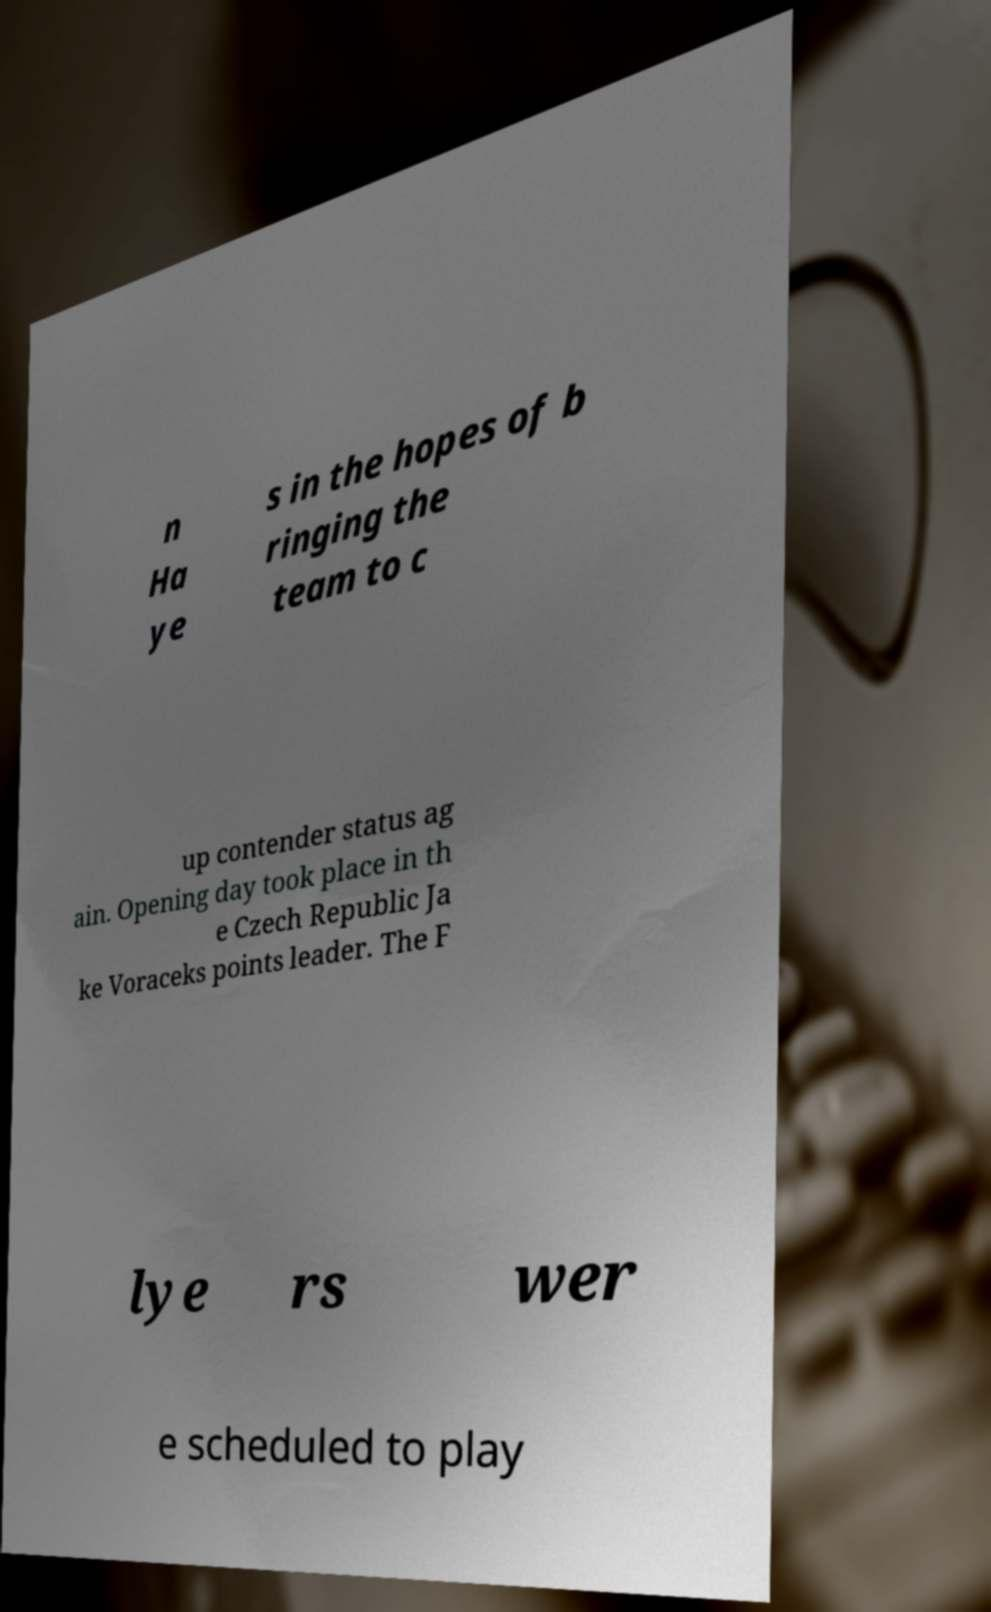Please read and relay the text visible in this image. What does it say? n Ha ye s in the hopes of b ringing the team to c up contender status ag ain. Opening day took place in th e Czech Republic Ja ke Voraceks points leader. The F lye rs wer e scheduled to play 